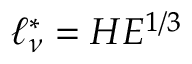<formula> <loc_0><loc_0><loc_500><loc_500>\ell _ { \nu } ^ { * } = H E ^ { 1 / 3 }</formula> 